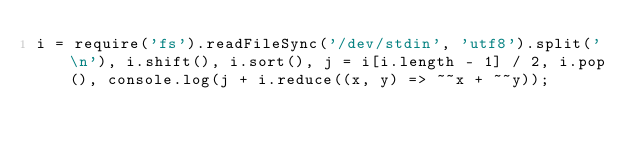<code> <loc_0><loc_0><loc_500><loc_500><_JavaScript_>i = require('fs').readFileSync('/dev/stdin', 'utf8').split('\n'), i.shift(), i.sort(), j = i[i.length - 1] / 2, i.pop(), console.log(j + i.reduce((x, y) => ~~x + ~~y));</code> 